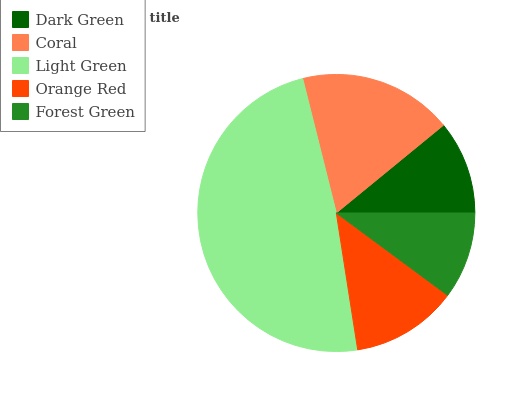Is Forest Green the minimum?
Answer yes or no. Yes. Is Light Green the maximum?
Answer yes or no. Yes. Is Coral the minimum?
Answer yes or no. No. Is Coral the maximum?
Answer yes or no. No. Is Coral greater than Dark Green?
Answer yes or no. Yes. Is Dark Green less than Coral?
Answer yes or no. Yes. Is Dark Green greater than Coral?
Answer yes or no. No. Is Coral less than Dark Green?
Answer yes or no. No. Is Orange Red the high median?
Answer yes or no. Yes. Is Orange Red the low median?
Answer yes or no. Yes. Is Light Green the high median?
Answer yes or no. No. Is Forest Green the low median?
Answer yes or no. No. 